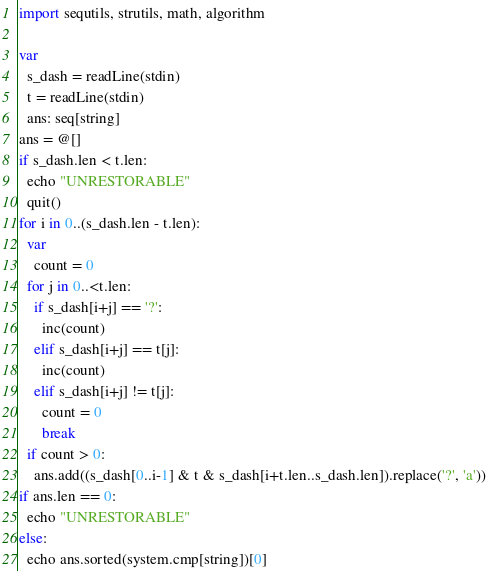<code> <loc_0><loc_0><loc_500><loc_500><_Nim_>import sequtils, strutils, math, algorithm

var
  s_dash = readLine(stdin)
  t = readLine(stdin)
  ans: seq[string]
ans = @[]
if s_dash.len < t.len:
  echo "UNRESTORABLE"
  quit()
for i in 0..(s_dash.len - t.len):
  var
    count = 0
  for j in 0..<t.len:
    if s_dash[i+j] == '?':
      inc(count)
    elif s_dash[i+j] == t[j]:
      inc(count)
    elif s_dash[i+j] != t[j]:
      count = 0
      break
  if count > 0:
    ans.add((s_dash[0..i-1] & t & s_dash[i+t.len..s_dash.len]).replace('?', 'a'))
if ans.len == 0:
  echo "UNRESTORABLE"
else:
  echo ans.sorted(system.cmp[string])[0]</code> 